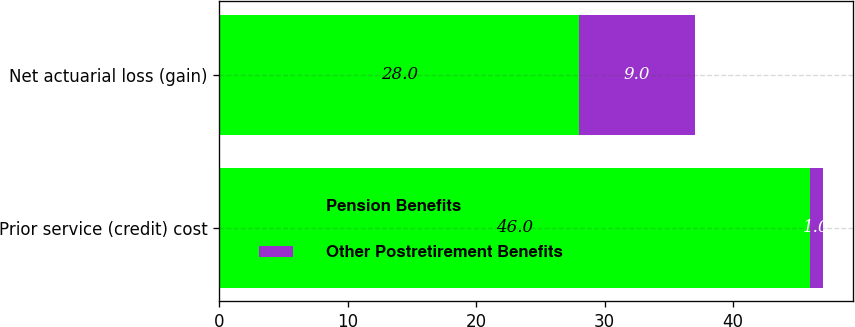<chart> <loc_0><loc_0><loc_500><loc_500><stacked_bar_chart><ecel><fcel>Prior service (credit) cost<fcel>Net actuarial loss (gain)<nl><fcel>Pension Benefits<fcel>46<fcel>28<nl><fcel>Other Postretirement Benefits<fcel>1<fcel>9<nl></chart> 